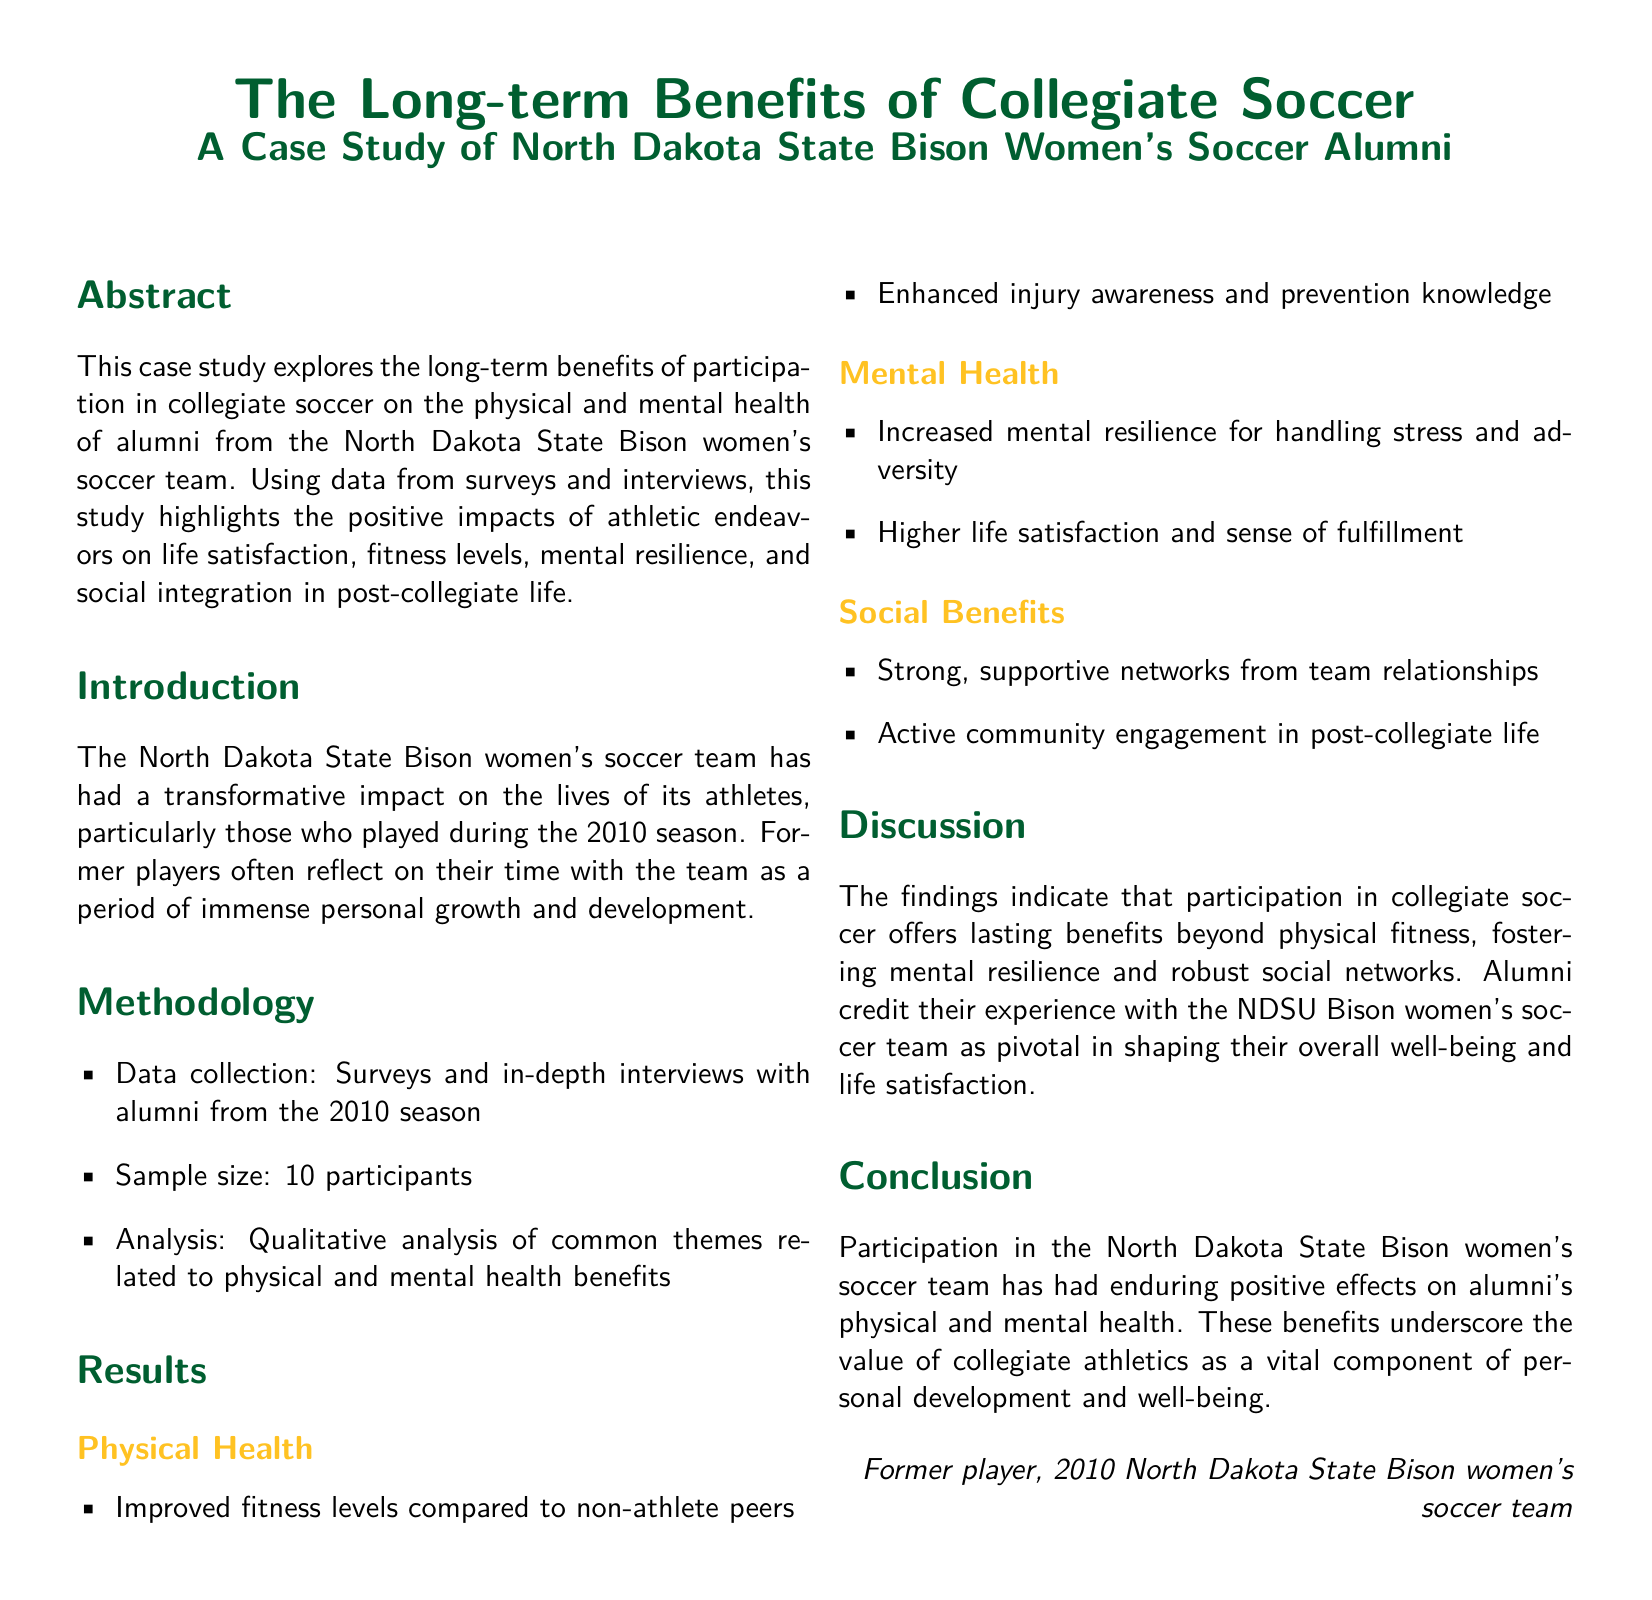What is the focus of the case study? The case study explores the long-term benefits of collegiate soccer on health and well-being of alumni.
Answer: long-term benefits of collegiate soccer How many participants were involved in the study? The sample size mentioned in the methodology indicates the number of participants.
Answer: 10 participants What were the two main health areas addressed in the results? The results section presents key areas regarding alumni health benefits.
Answer: Physical Health, Mental Health Which women's soccer team is the subject of the case study? The title indicates the specific team being studied in this case.
Answer: North Dakota State Bison women's soccer team What type of analysis was used in the study? The methodology section specifies the kind of analysis that was performed on the collected data.
Answer: Qualitative analysis How did alumni describe their satisfaction post-collegiate participation? The findings in the results section reflect on the feelings of alumni.
Answer: Higher life satisfaction What is one of the social benefits mentioned in the results? The results include a discussion of social aspects contributing to alumni life after college.
Answer: Strong, supportive networks What does the conclusion highlight about participation in collegiate soccer? The conclusion summarizes the primary takeaway of the benefits from involvement in collegiate soccer.
Answer: Enduring positive effects What method was used for data collection? The methodology outlines the way data was gathered for analysis.
Answer: Surveys and in-depth interviews 